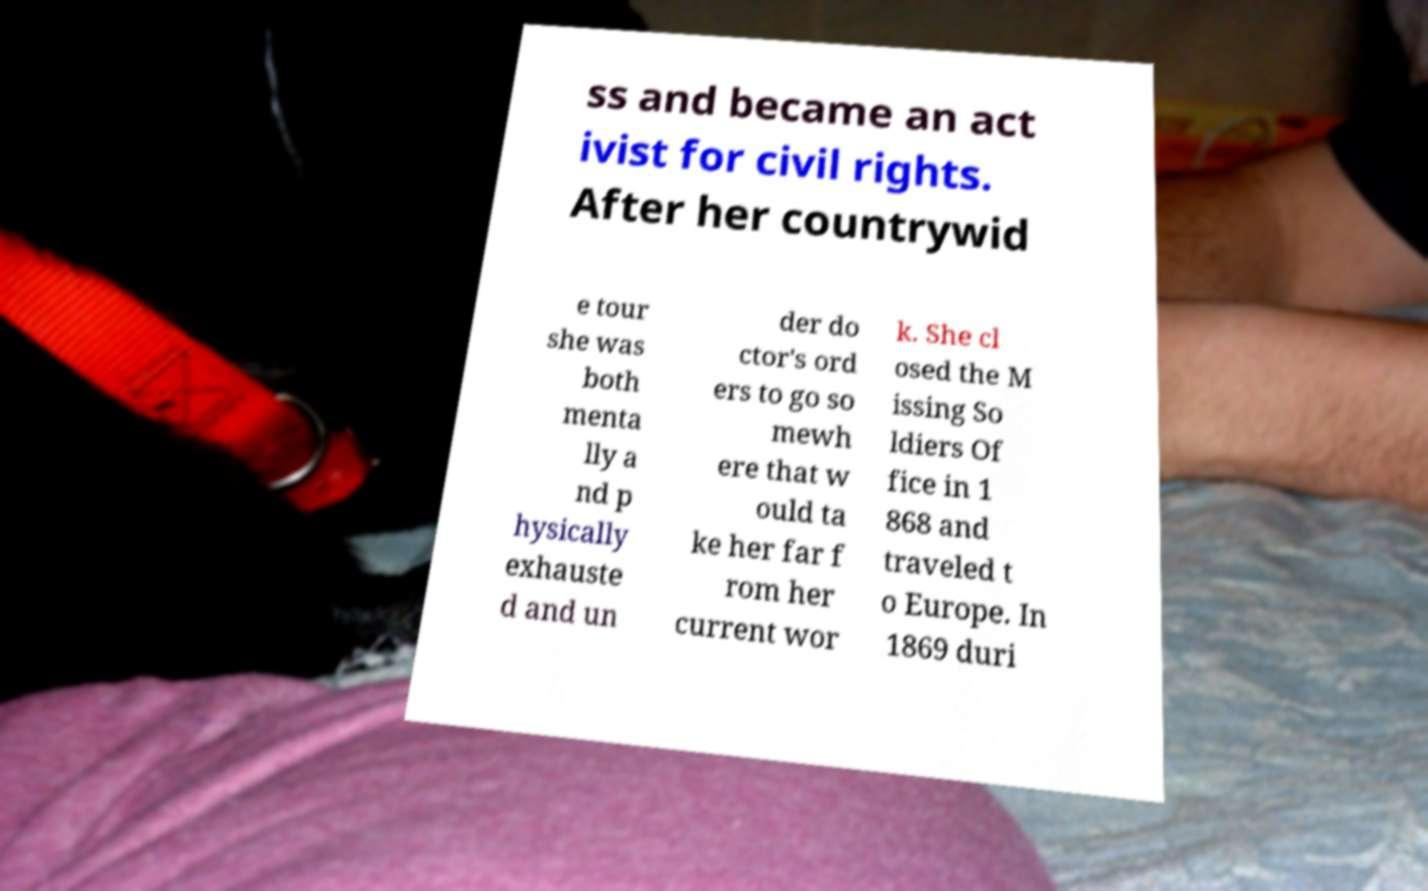There's text embedded in this image that I need extracted. Can you transcribe it verbatim? ss and became an act ivist for civil rights. After her countrywid e tour she was both menta lly a nd p hysically exhauste d and un der do ctor's ord ers to go so mewh ere that w ould ta ke her far f rom her current wor k. She cl osed the M issing So ldiers Of fice in 1 868 and traveled t o Europe. In 1869 duri 